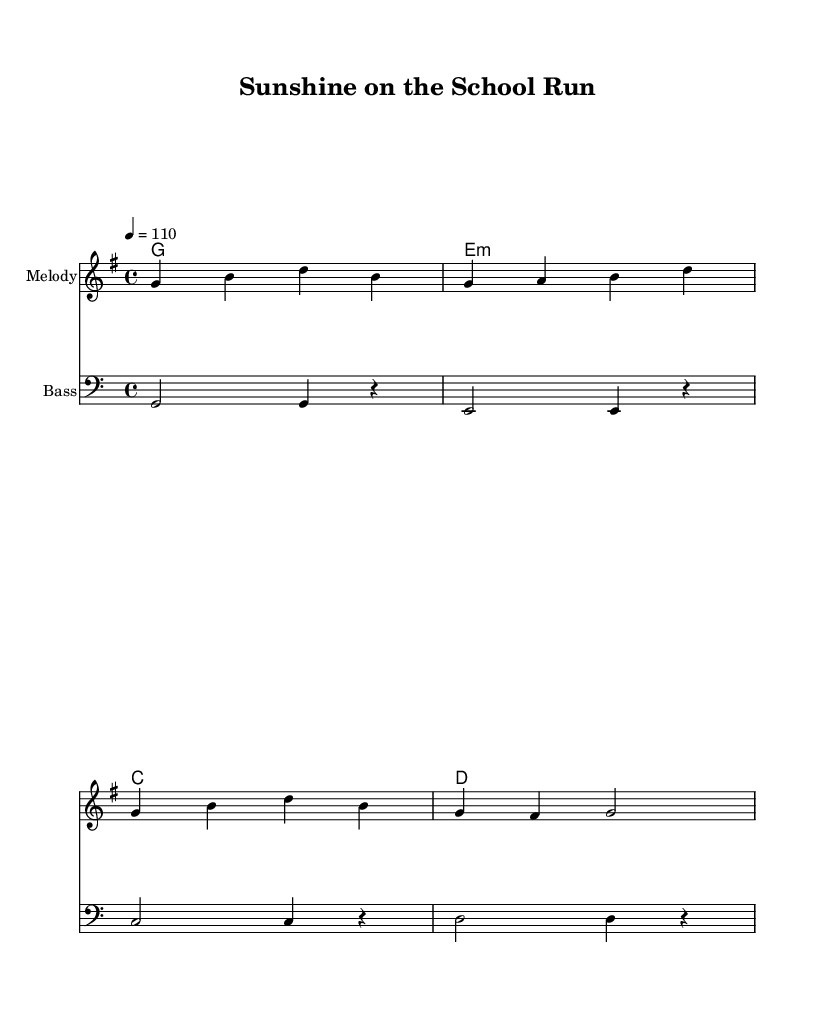What is the key signature of this music? The key signature is G major, which has one sharp (F#).
Answer: G major What is the time signature of this music? The time signature is 4/4, meaning there are four beats in each measure.
Answer: 4/4 What is the tempo marking of the piece? The tempo marking is quarter note equals 110 beats per minute, indicating a moderately fast pace.
Answer: 110 What chords are used in the first measure of the harmonies? The first measure has the G major chord, as indicated by the letter G followed by the numeral 1 for a whole note.
Answer: G How does the melody compare to the bass in terms of pitch range? The melody is played in a higher pitch range, as indicated by the use of treble clef, while the bass is in a lower range indicated by bass clef.
Answer: Higher Which section has a repeated note? The melody has a repeated note on the G in the second measure, as it appears in both the first and second beats.
Answer: G 